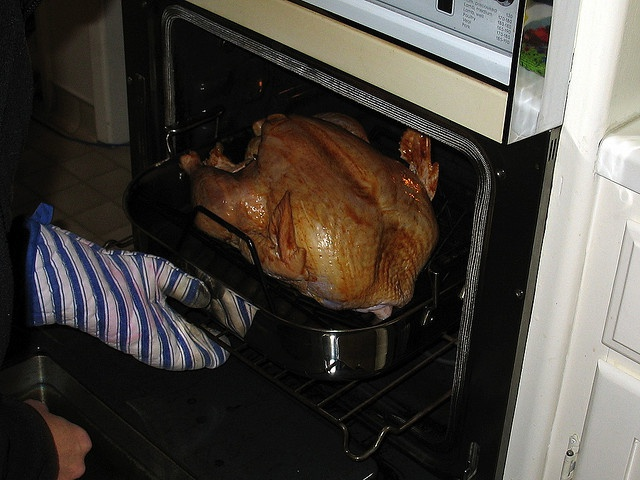Describe the objects in this image and their specific colors. I can see oven in black, maroon, and darkgray tones and people in black, navy, darkgray, and gray tones in this image. 